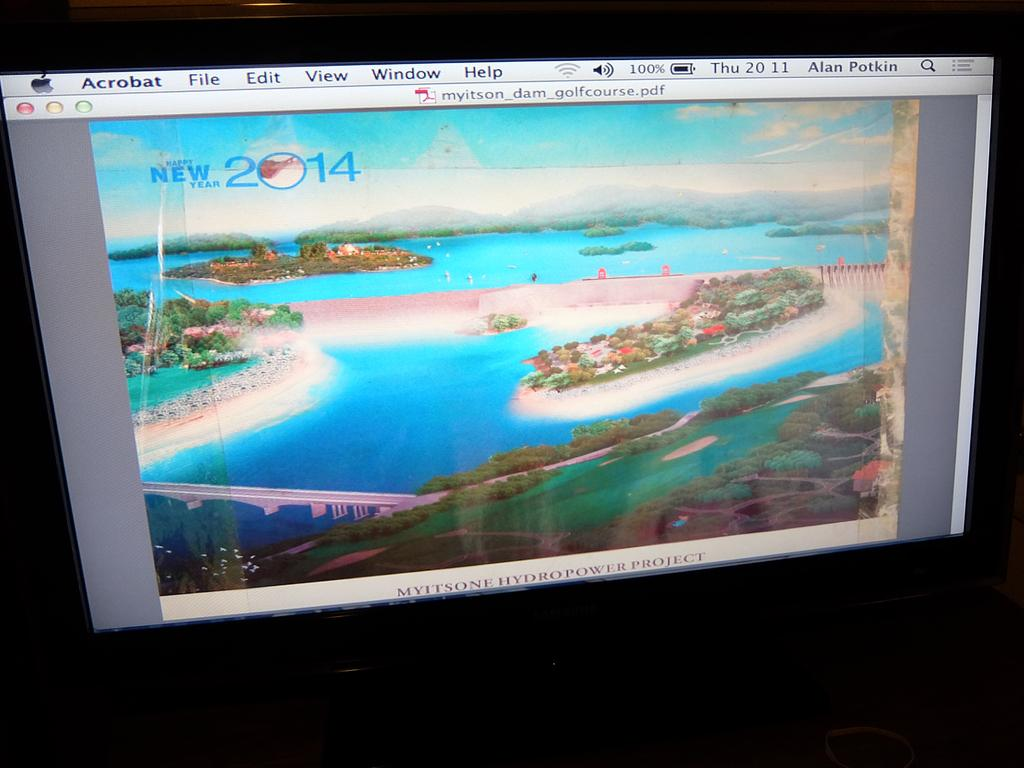<image>
Relay a brief, clear account of the picture shown. acrobat is a program with a nice image on it 